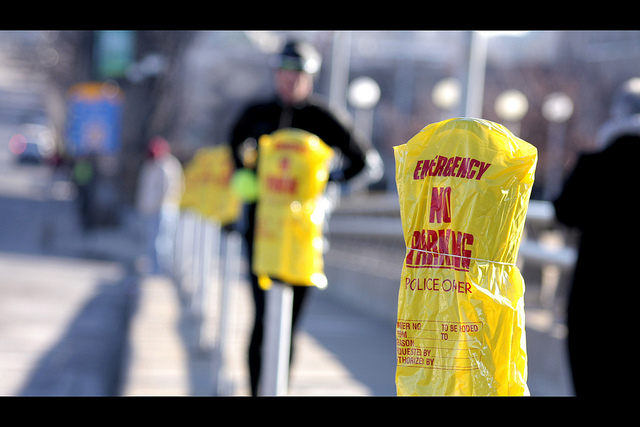Identify and read out the text in this image. NI 61 